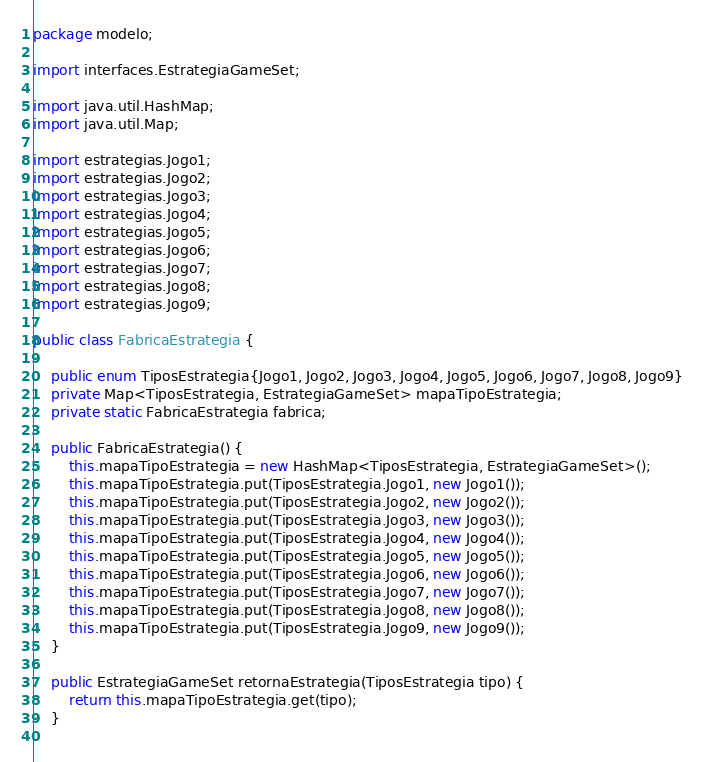Convert code to text. <code><loc_0><loc_0><loc_500><loc_500><_Java_>package modelo;

import interfaces.EstrategiaGameSet;

import java.util.HashMap;
import java.util.Map;

import estrategias.Jogo1;
import estrategias.Jogo2;
import estrategias.Jogo3;
import estrategias.Jogo4;
import estrategias.Jogo5;
import estrategias.Jogo6;
import estrategias.Jogo7;
import estrategias.Jogo8;
import estrategias.Jogo9;

public class FabricaEstrategia {

	public enum TiposEstrategia{Jogo1, Jogo2, Jogo3, Jogo4, Jogo5, Jogo6, Jogo7, Jogo8, Jogo9}
	private Map<TiposEstrategia, EstrategiaGameSet> mapaTipoEstrategia;
	private static FabricaEstrategia fabrica;
	
	public FabricaEstrategia() {
		this.mapaTipoEstrategia = new HashMap<TiposEstrategia, EstrategiaGameSet>();
		this.mapaTipoEstrategia.put(TiposEstrategia.Jogo1, new Jogo1());
		this.mapaTipoEstrategia.put(TiposEstrategia.Jogo2, new Jogo2());
		this.mapaTipoEstrategia.put(TiposEstrategia.Jogo3, new Jogo3());
		this.mapaTipoEstrategia.put(TiposEstrategia.Jogo4, new Jogo4());
		this.mapaTipoEstrategia.put(TiposEstrategia.Jogo5, new Jogo5());
		this.mapaTipoEstrategia.put(TiposEstrategia.Jogo6, new Jogo6());
		this.mapaTipoEstrategia.put(TiposEstrategia.Jogo7, new Jogo7());
		this.mapaTipoEstrategia.put(TiposEstrategia.Jogo8, new Jogo8());
		this.mapaTipoEstrategia.put(TiposEstrategia.Jogo9, new Jogo9());
	}
	
	public EstrategiaGameSet retornaEstrategia(TiposEstrategia tipo) {
		return this.mapaTipoEstrategia.get(tipo);
	}
	</code> 